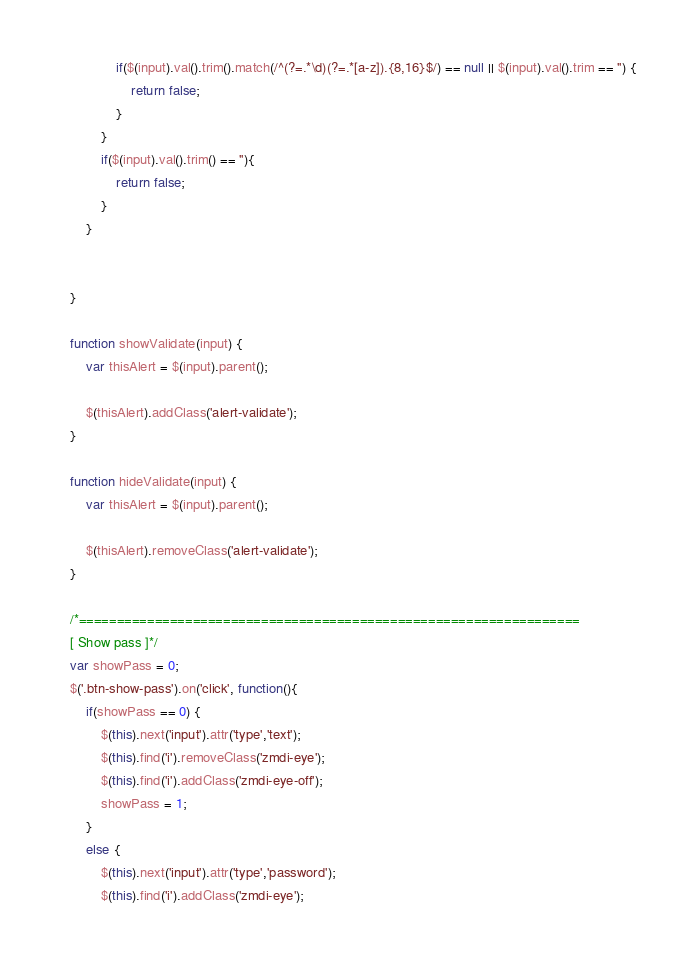Convert code to text. <code><loc_0><loc_0><loc_500><loc_500><_JavaScript_>                if($(input).val().trim().match(/^(?=.*\d)(?=.*[a-z]).{8,16}$/) == null || $(input).val().trim == '') {
                    return false;
                } 
            }
            if($(input).val().trim() == ''){
                return false;
            }
        }


    }

    function showValidate(input) {
        var thisAlert = $(input).parent();

        $(thisAlert).addClass('alert-validate');
    }

    function hideValidate(input) {
        var thisAlert = $(input).parent();

        $(thisAlert).removeClass('alert-validate');
    }
    
    /*==================================================================
    [ Show pass ]*/
    var showPass = 0;
    $('.btn-show-pass').on('click', function(){
        if(showPass == 0) {
            $(this).next('input').attr('type','text');
            $(this).find('i').removeClass('zmdi-eye');
            $(this).find('i').addClass('zmdi-eye-off');
            showPass = 1;
        }
        else {
            $(this).next('input').attr('type','password');
            $(this).find('i').addClass('zmdi-eye');</code> 